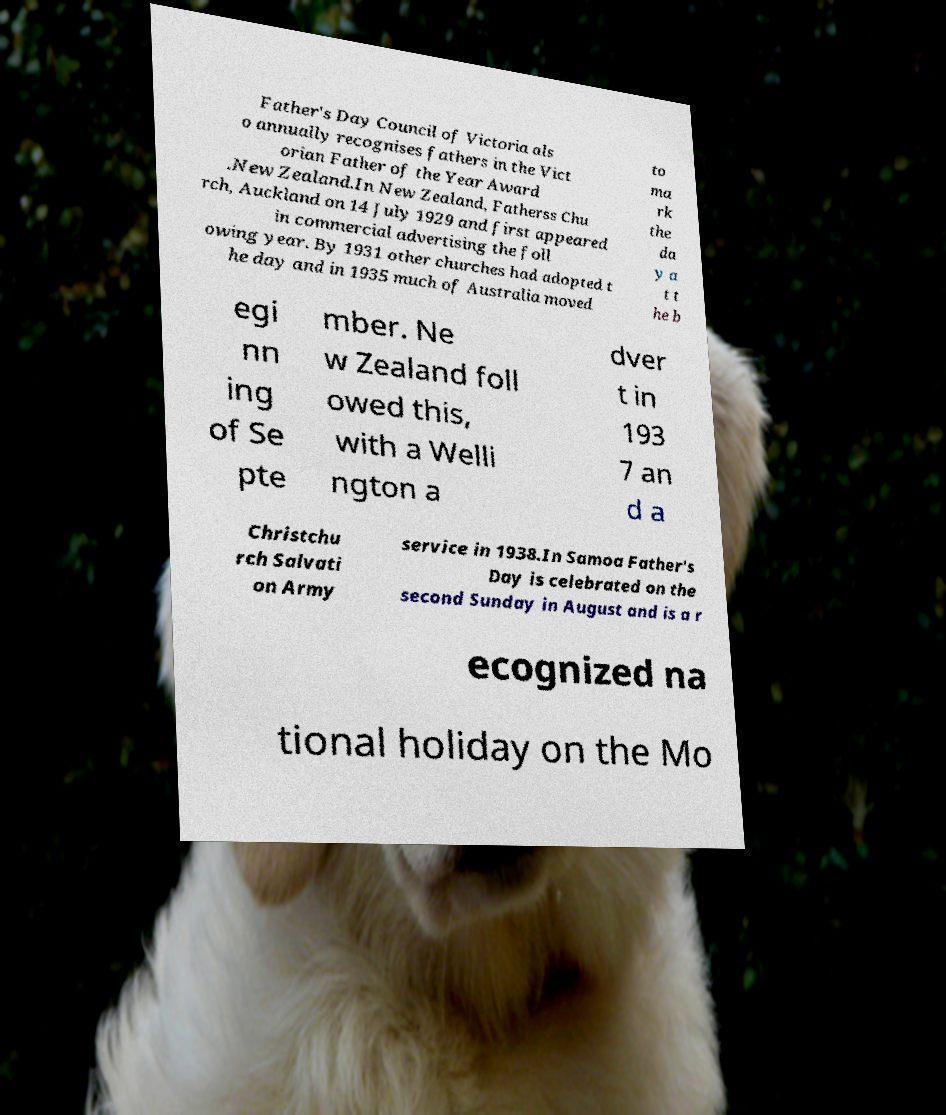Could you assist in decoding the text presented in this image and type it out clearly? Father's Day Council of Victoria als o annually recognises fathers in the Vict orian Father of the Year Award .New Zealand.In New Zealand, Fatherss Chu rch, Auckland on 14 July 1929 and first appeared in commercial advertising the foll owing year. By 1931 other churches had adopted t he day and in 1935 much of Australia moved to ma rk the da y a t t he b egi nn ing of Se pte mber. Ne w Zealand foll owed this, with a Welli ngton a dver t in 193 7 an d a Christchu rch Salvati on Army service in 1938.In Samoa Father's Day is celebrated on the second Sunday in August and is a r ecognized na tional holiday on the Mo 